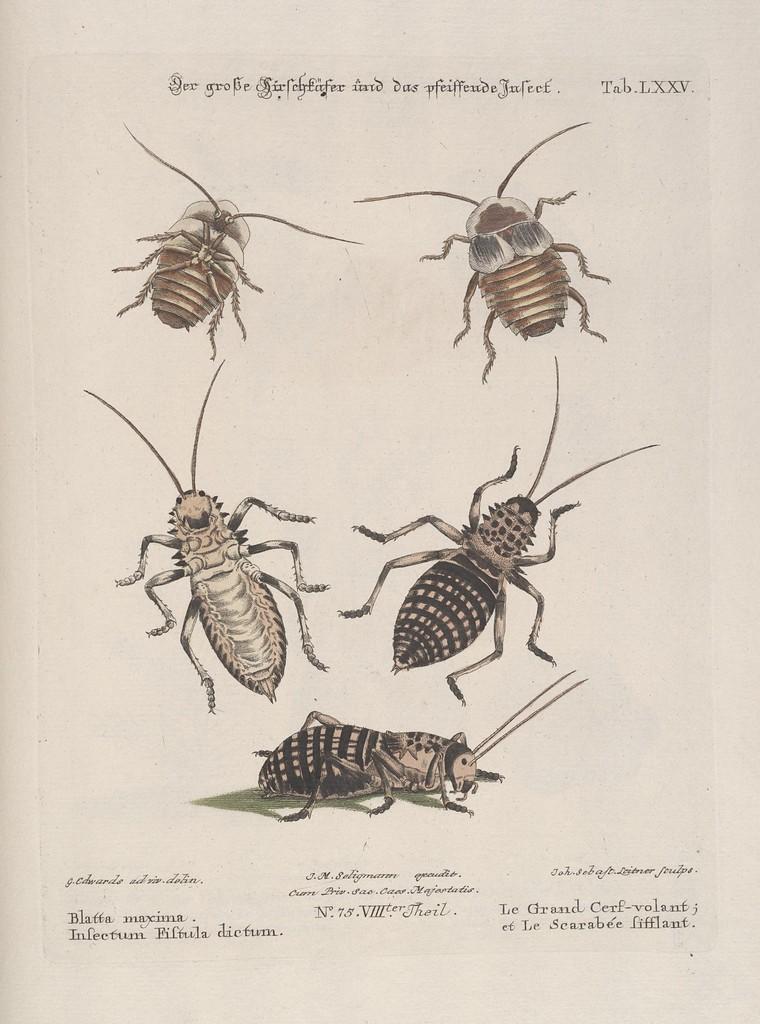Describe this image in one or two sentences. It is a poster. In this image there is a depiction of cockroaches and there is some text written on the top and bottom of the image. 